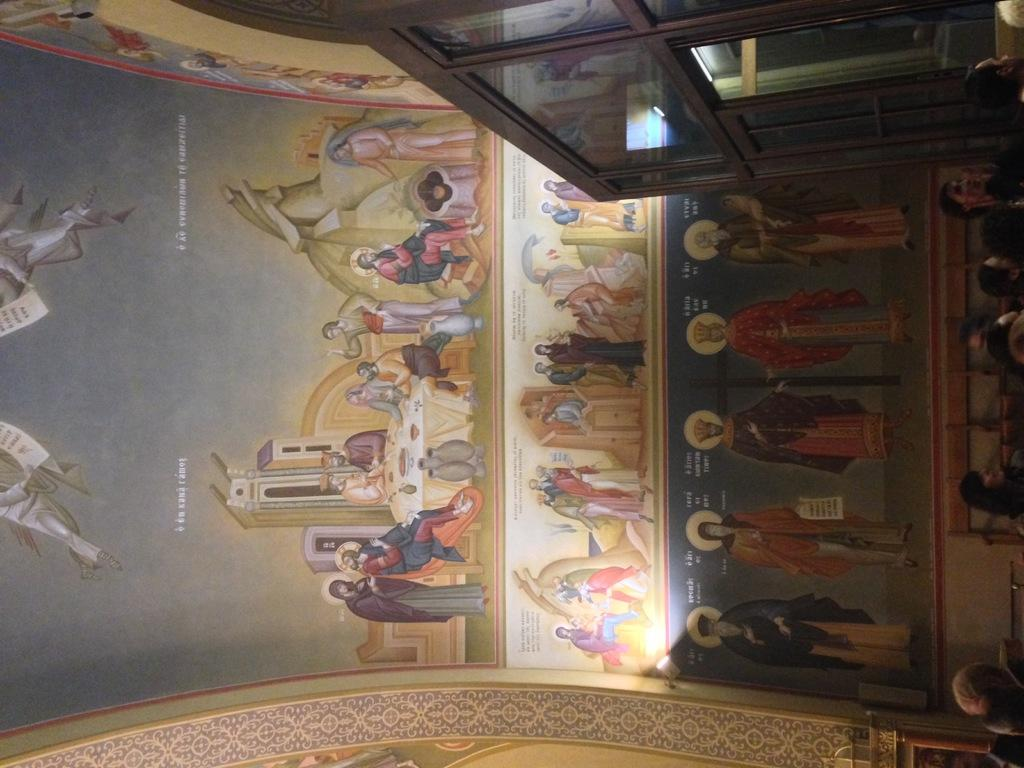What is on the wall in the image? There is a painting on the wall in the image. What is happening in front of the wall? There are people standing in front of the wall. Can you describe the structure beside the people? There is a wooden structure with glass beside the people. What type of card is being played by the people in the image? There is no card or card game present in the image. What time of day is depicted in the image? The time of day is not indicated in the image. 